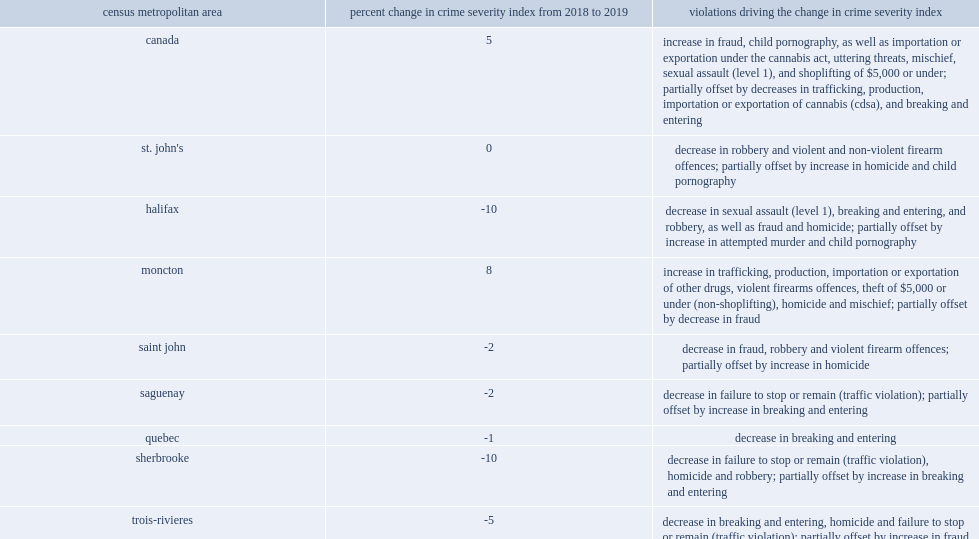What was the largest decreases in csi between 2018 and 2019 were reported in brantford? -10.0. What was the largest decreases in csi between 2018 and 2019 were reported in sherbrooke? -10.0. What was the largest decreases in csi between 2018 and 2019 were reported in sherbrooke? -10.0. What was the largest decreases in csi between 2018 and 2019 were reported in sherbrooke? -9.0. 